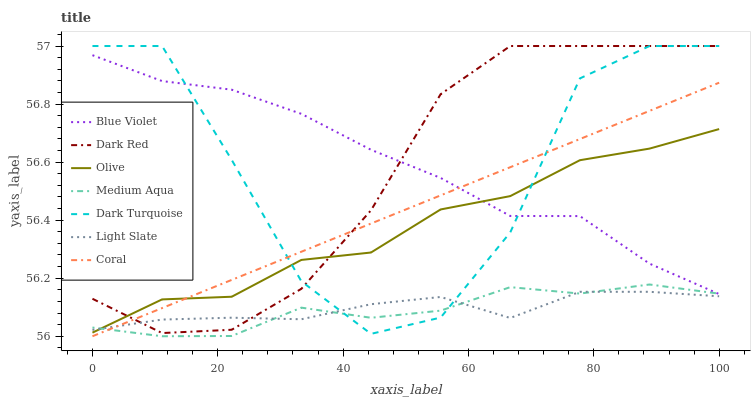Does Medium Aqua have the minimum area under the curve?
Answer yes or no. Yes. Does Blue Violet have the maximum area under the curve?
Answer yes or no. Yes. Does Dark Red have the minimum area under the curve?
Answer yes or no. No. Does Dark Red have the maximum area under the curve?
Answer yes or no. No. Is Coral the smoothest?
Answer yes or no. Yes. Is Dark Turquoise the roughest?
Answer yes or no. Yes. Is Dark Red the smoothest?
Answer yes or no. No. Is Dark Red the roughest?
Answer yes or no. No. Does Dark Red have the lowest value?
Answer yes or no. No. Does Coral have the highest value?
Answer yes or no. No. Is Light Slate less than Blue Violet?
Answer yes or no. Yes. Is Blue Violet greater than Light Slate?
Answer yes or no. Yes. Does Light Slate intersect Blue Violet?
Answer yes or no. No. 